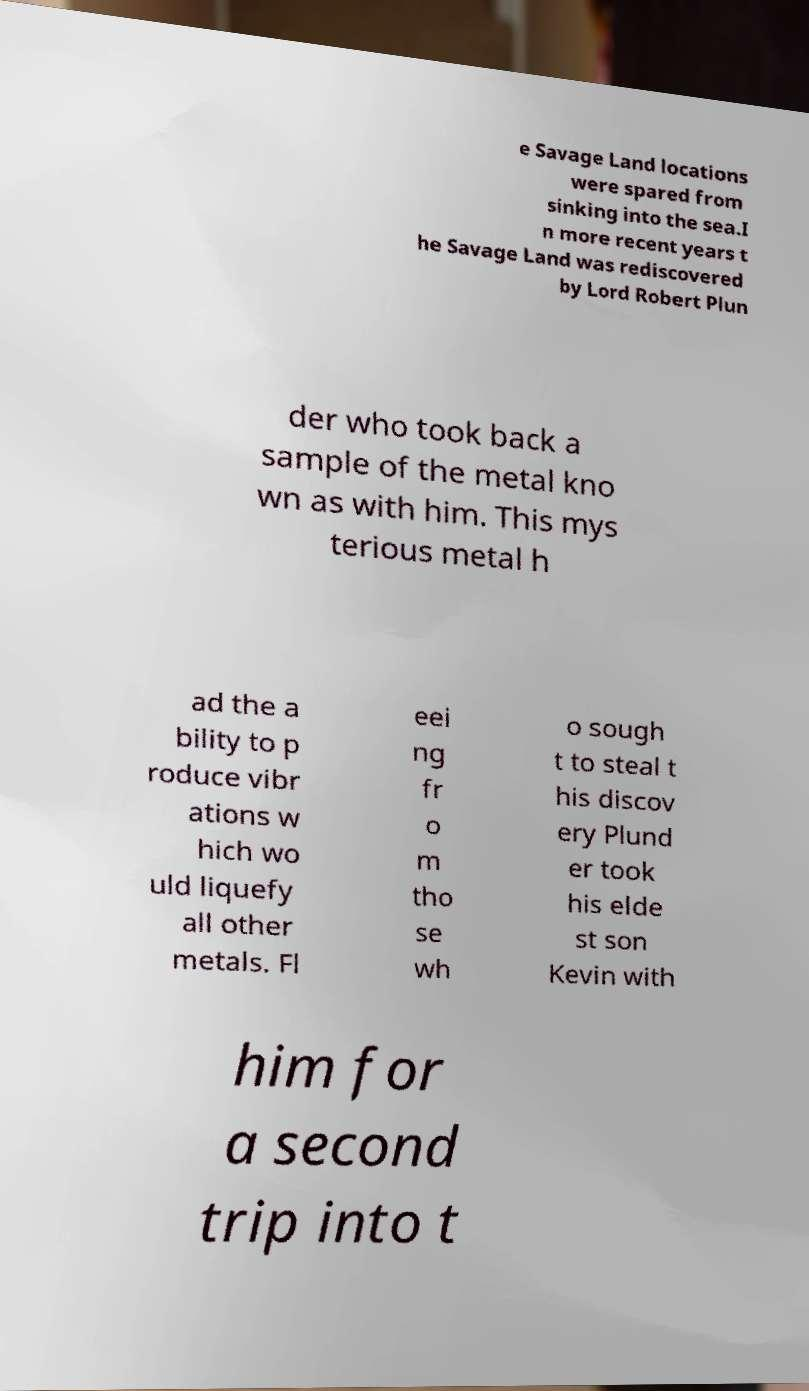I need the written content from this picture converted into text. Can you do that? e Savage Land locations were spared from sinking into the sea.I n more recent years t he Savage Land was rediscovered by Lord Robert Plun der who took back a sample of the metal kno wn as with him. This mys terious metal h ad the a bility to p roduce vibr ations w hich wo uld liquefy all other metals. Fl eei ng fr o m tho se wh o sough t to steal t his discov ery Plund er took his elde st son Kevin with him for a second trip into t 